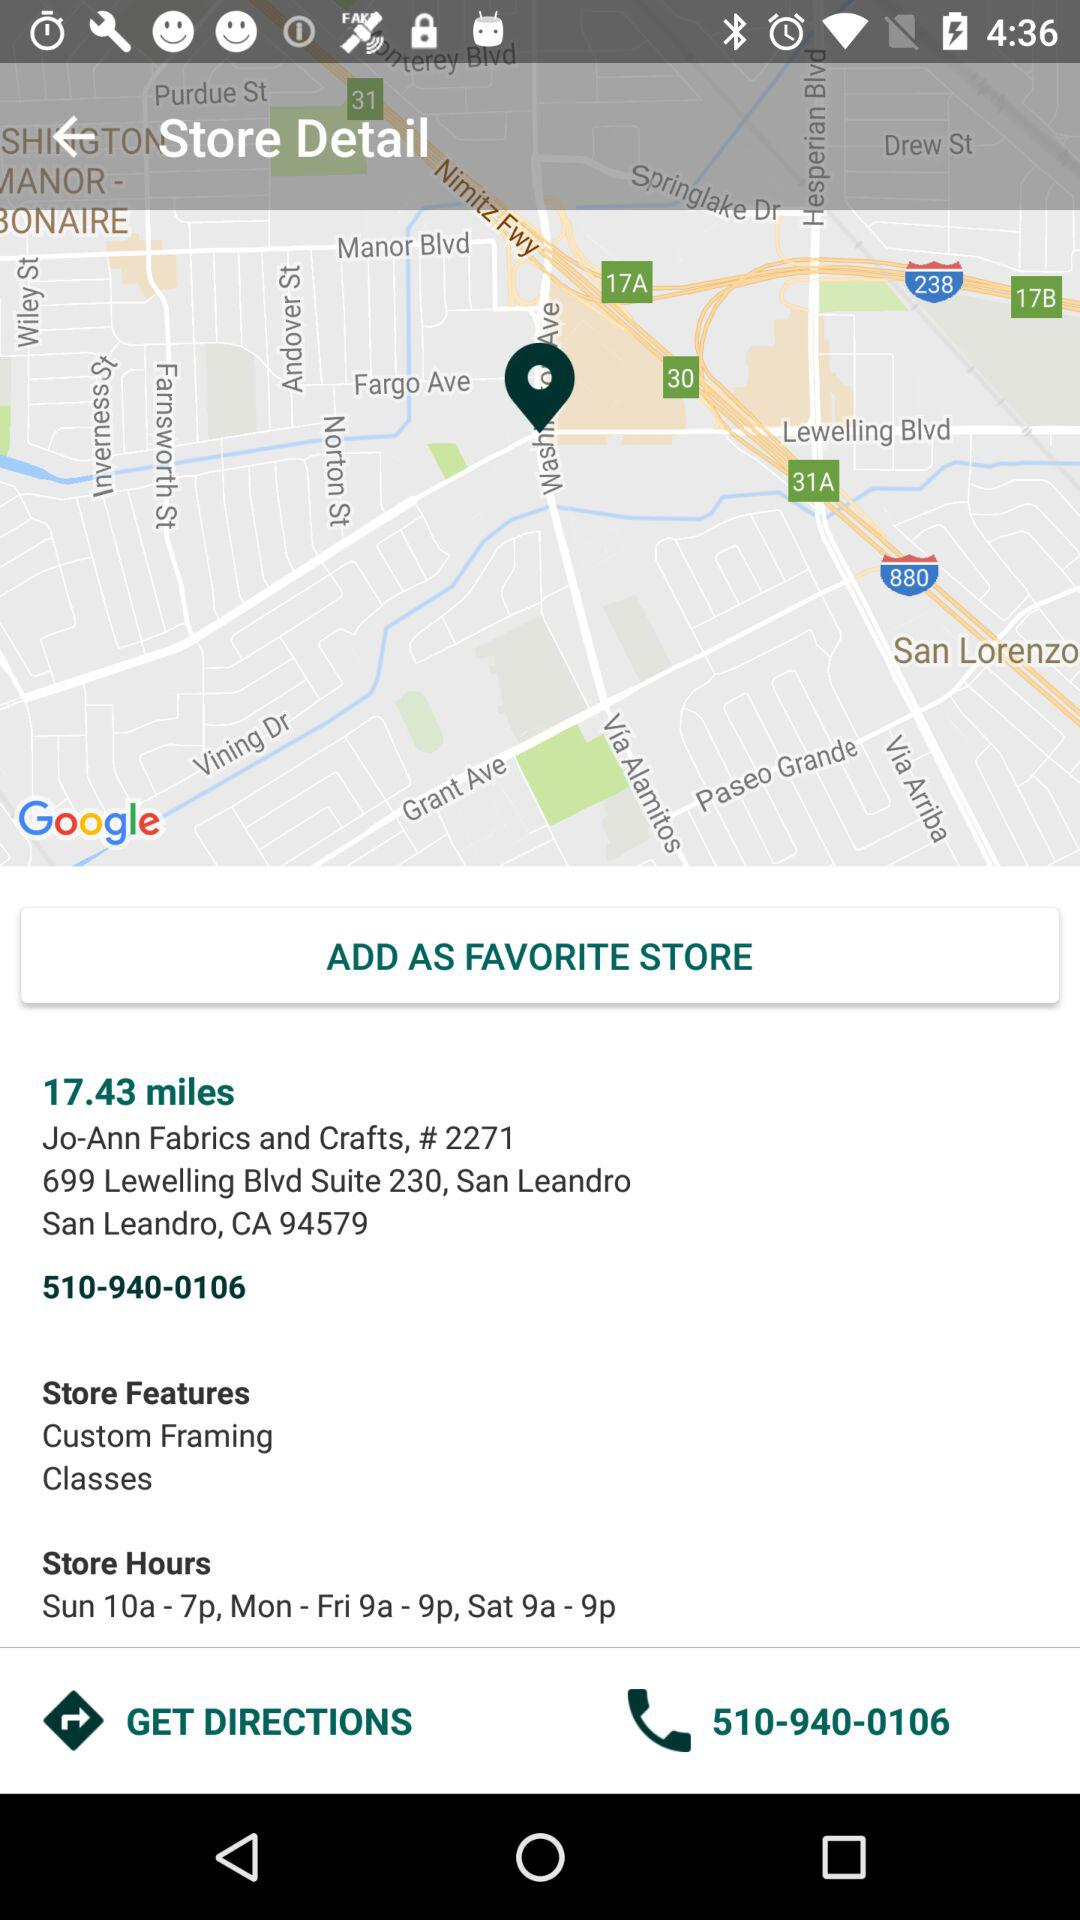What are the store's hours?
Answer the question using a single word or phrase. Sun 10a - 7p, Mon - Fri 9a - 9p, Sat 9a - 9p 